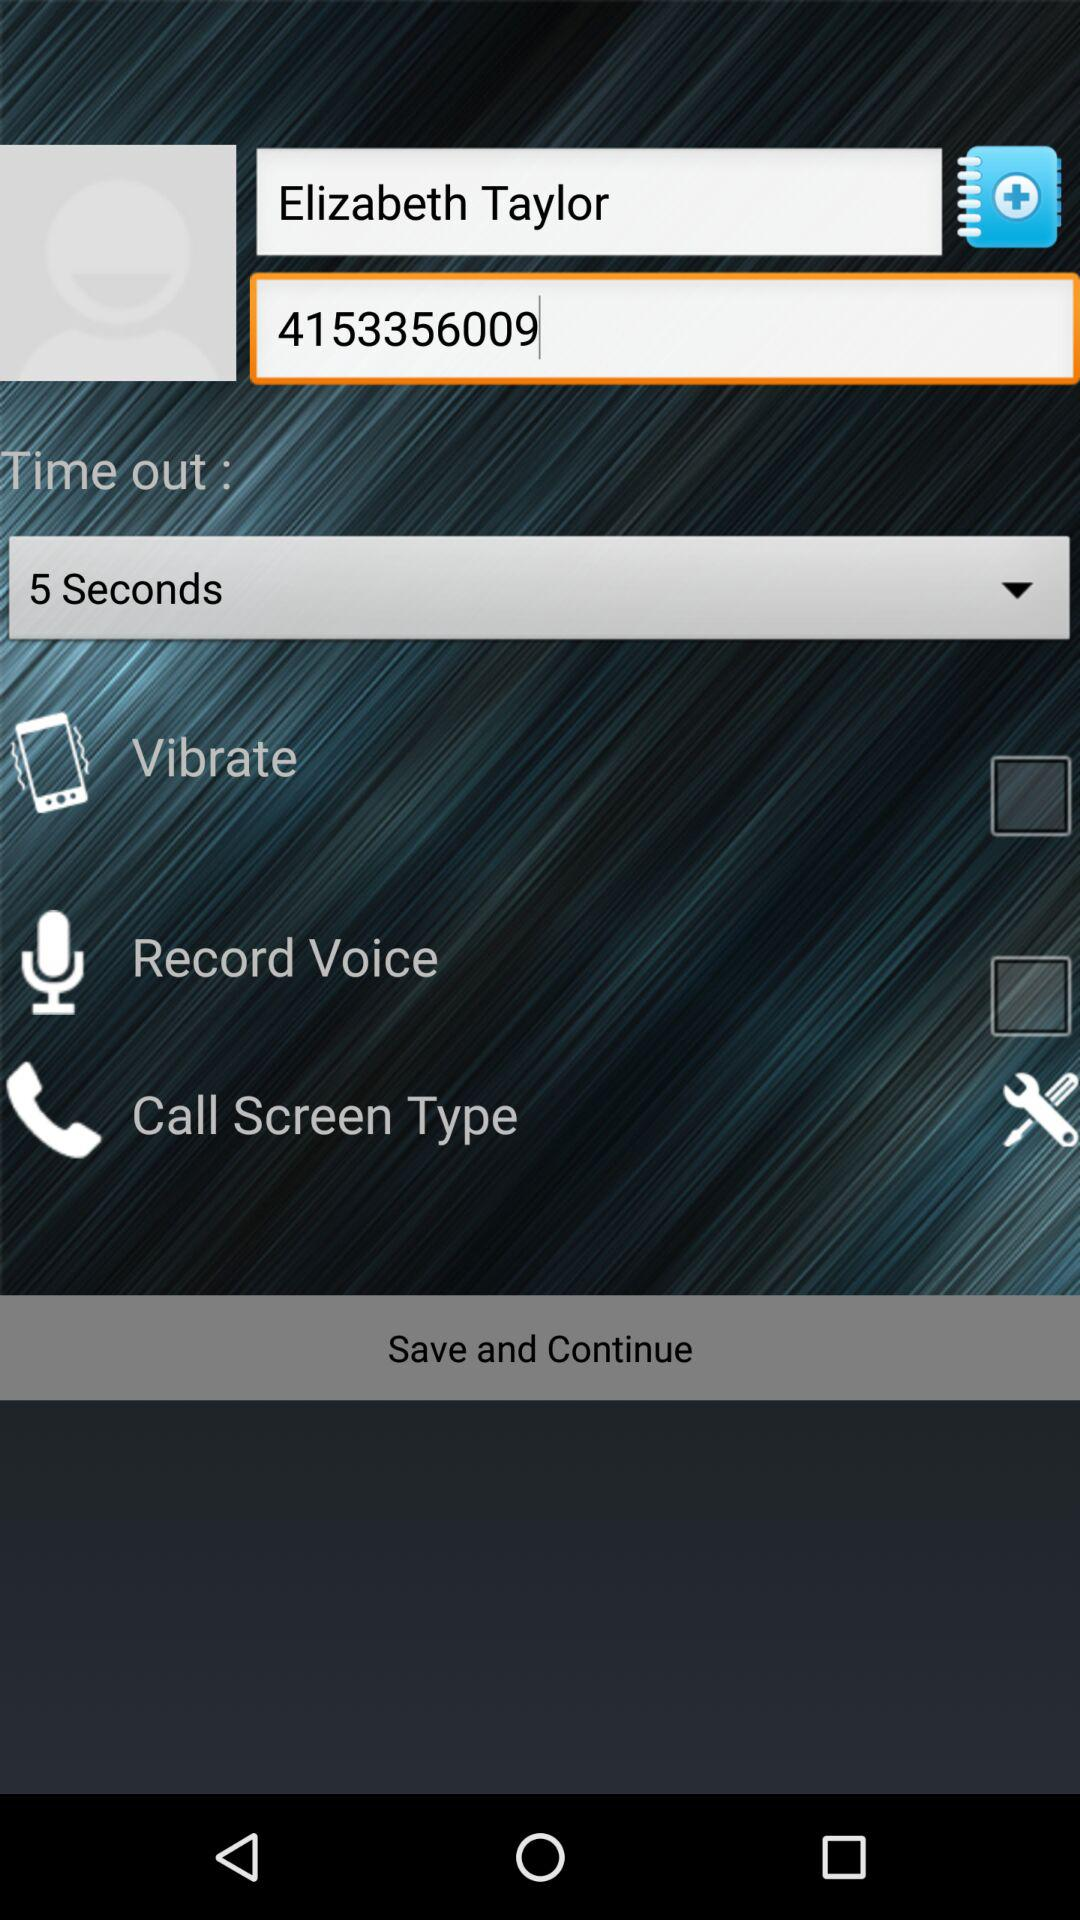What is the status of "Vibrate"? The status is "off". 